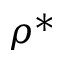Convert formula to latex. <formula><loc_0><loc_0><loc_500><loc_500>\rho ^ { * }</formula> 